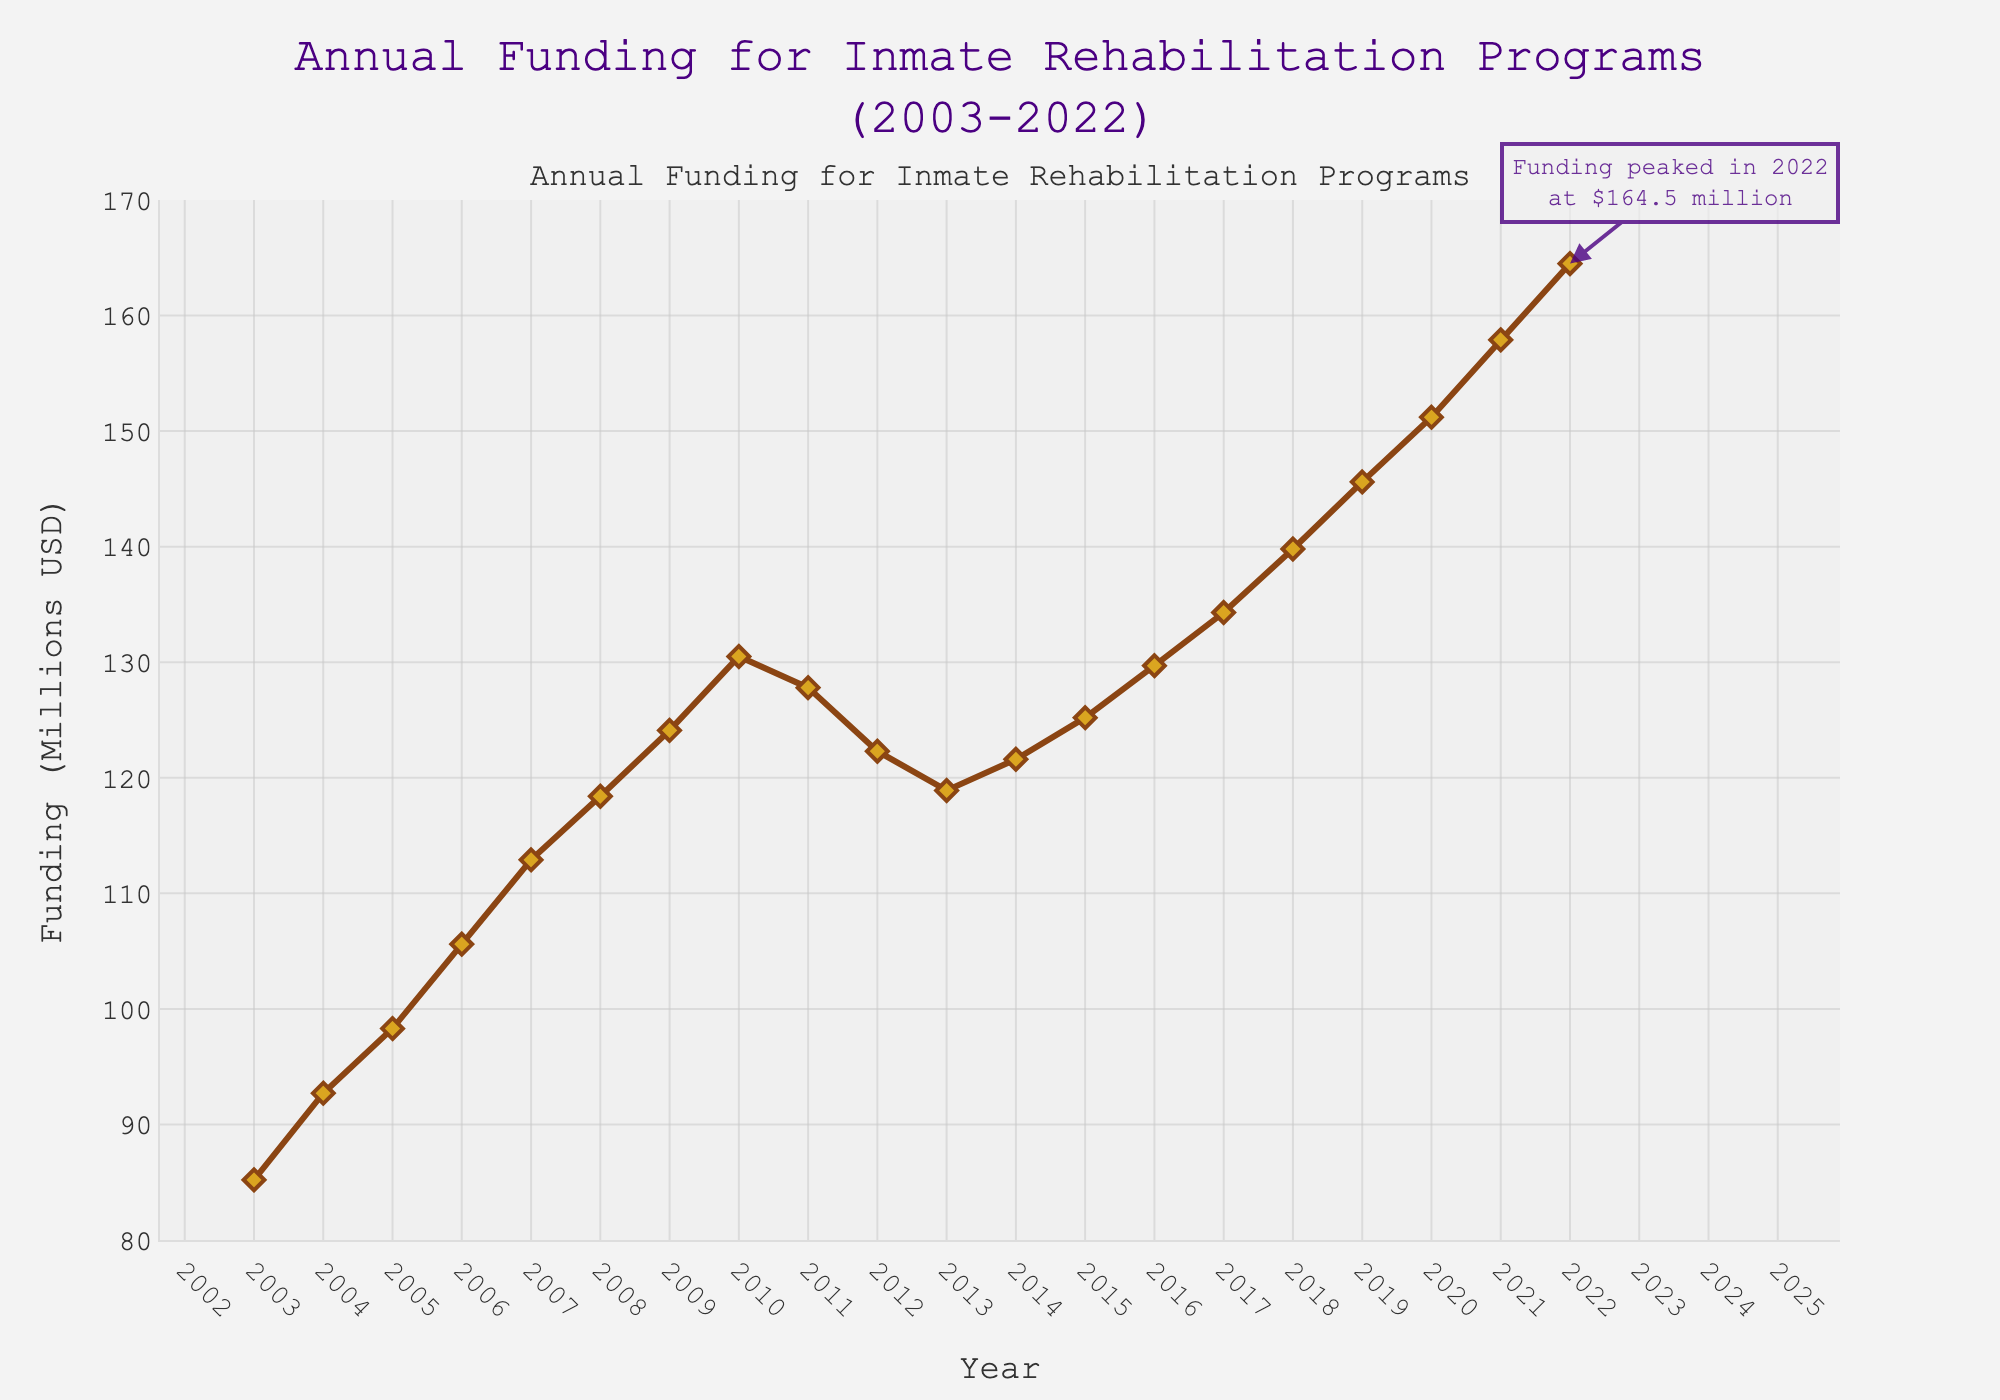What is the peak funding value according to the chart? The annotation on the chart indicates that the funding peaked at $164.5 million in 2022. This is clearly marked by a note on the figure.
Answer: $164.5 million How does the funding in 2022 compare to the funding in 2003? To find the difference, subtract the funding in 2003 from the funding in 2022. This is $164.5 million - $85.2 million = $79.3 million.
Answer: $79.3 million What is the general trend of the annual funding from 2003 to 2022? Looking at the plotted line, it generally increases over the years, with a small dip between 2010 and 2013, but eventually reaching a peak in 2022.
Answer: Increasing In which year did the funding experience a noticeable decrease for the first time, and how much was the decrease? The funding decreased from 2010 to 2011. The funding in 2010 was $130.5 million, while in 2011, it was $127.8 million. The decrease, therefore, is $130.5 million - $127.8 million = $2.7 million.
Answer: 2011, $2.7 million Which year had the lowest funding between 2003 and 2022, and what was the amount? According to the chart, the lowest funding amount was in 2003 at $85.2 million.
Answer: 2003, $85.2 million What's the mean funding from 2010 to 2020? First, sum up all the funding values from 2010 to 2020, which are: 130.5 + 127.8 + 122.3 + 118.9 + 121.6 + 125.2 + 129.7 + 134.3 + 139.8 + 145.6 + 151.2. The sum is 1346.9 million USD. There are 11 years, so the average is 1346.9/11 = 122.45 million USD.
Answer: 122.45 million USD Compare the funding trend before 2011 and after 2012. From 2003 to 2010, the trend is generally increasing. However, between 2011 and 2013, there is a decline in funding, and from 2014 onwards, the funding shows a steady increase again.
Answer: Increasing before 2011, Decrease then increase after 2012 How does the funding in 2015 compare to that in 2012? The funding in 2012 was $122.3 million, and in 2015, it was $125.2 million. Therefore, the funding in 2015 is higher than in 2012 by $125.2 million - $122.3 million = $2.9 million.
Answer: Higher by $2.9 million What is the average funding for the first decade (2003-2012)? Sum the funding from 2003 to 2012: 85.2 + 92.7 + 98.3 + 105.6 + 112.9 + 118.4 + 124.1 + 130.5 + 127.8 + 122.3. The sum is 1118.8 million USD. Since the span is 10 years, the average is 1118.8/10 = 111.88 million USD.
Answer: 111.88 million USD 